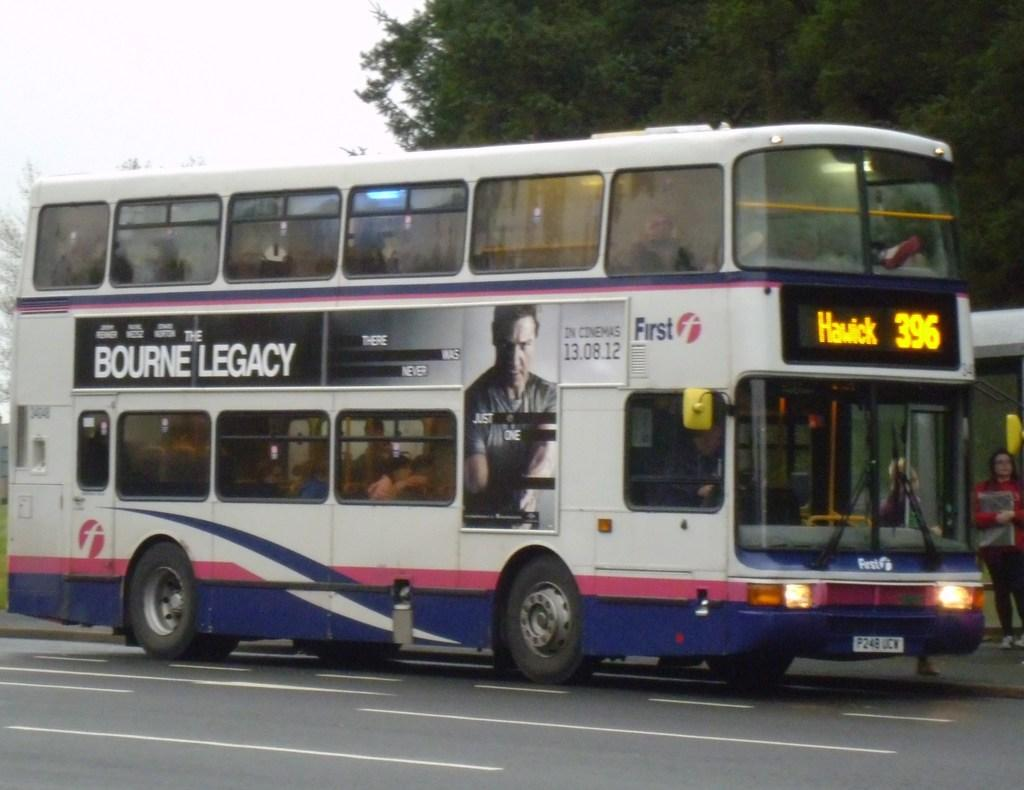<image>
Share a concise interpretation of the image provided. A double decker bus that is white and blue Hawick 396. 